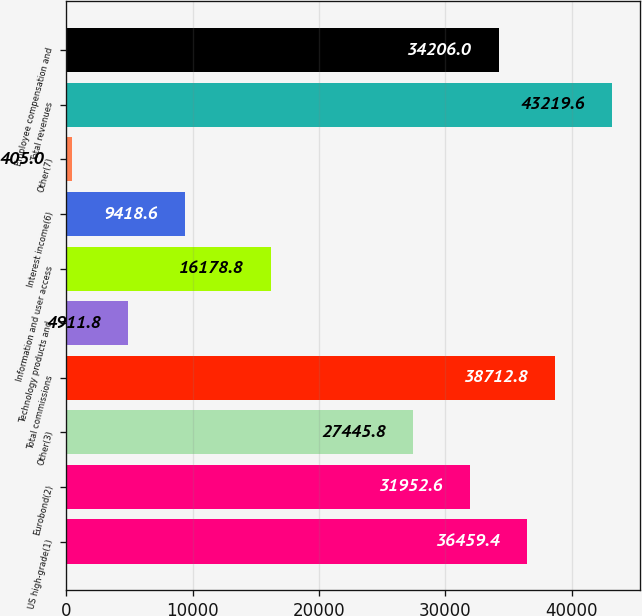Convert chart. <chart><loc_0><loc_0><loc_500><loc_500><bar_chart><fcel>US high-grade(1)<fcel>Eurobond(2)<fcel>Other(3)<fcel>Total commissions<fcel>Technology products and<fcel>Information and user access<fcel>Interest income(6)<fcel>Other(7)<fcel>Total revenues<fcel>Employee compensation and<nl><fcel>36459.4<fcel>31952.6<fcel>27445.8<fcel>38712.8<fcel>4911.8<fcel>16178.8<fcel>9418.6<fcel>405<fcel>43219.6<fcel>34206<nl></chart> 